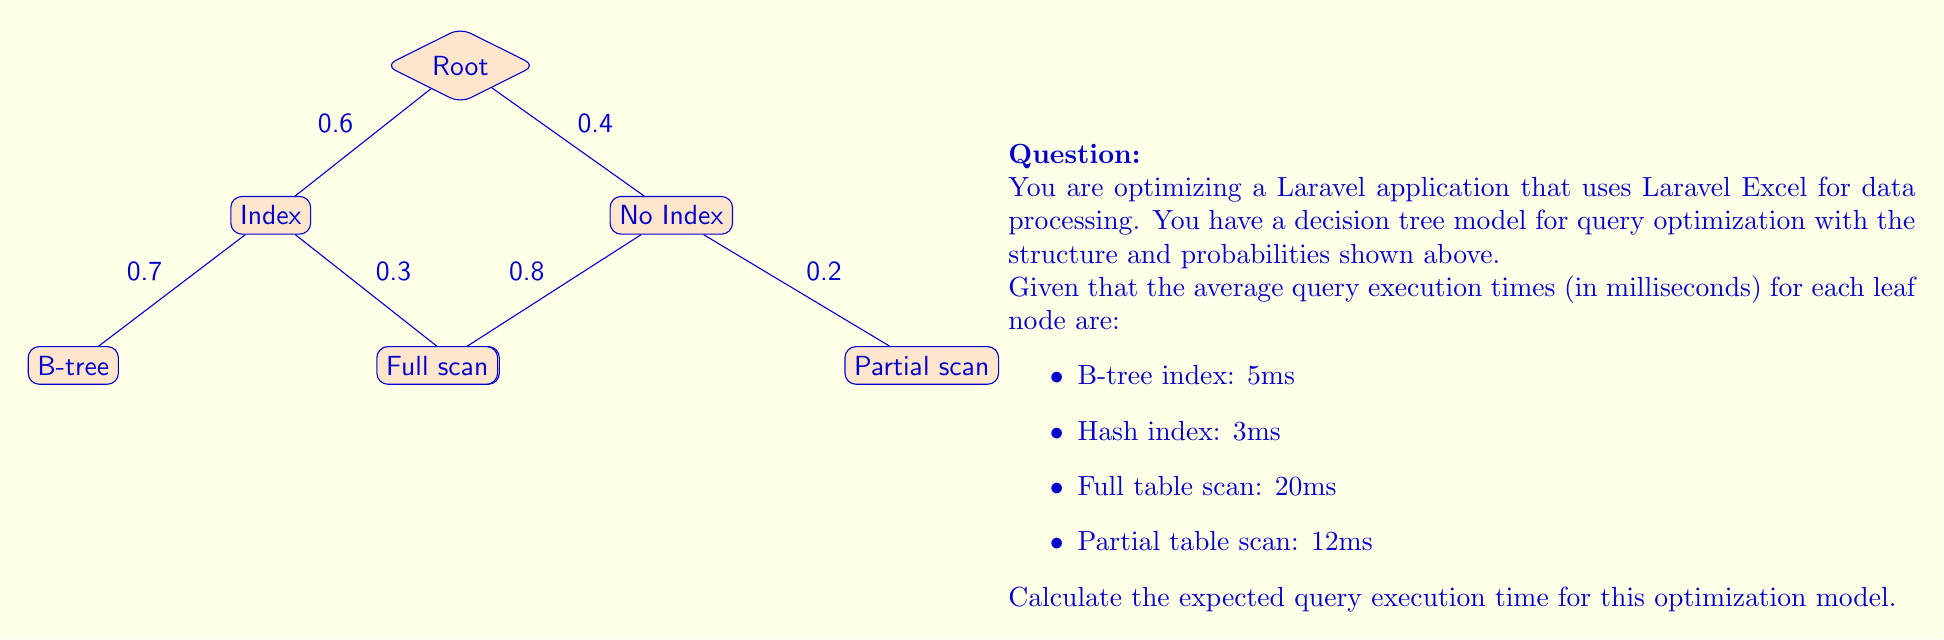Show me your answer to this math problem. To calculate the expected query execution time, we need to follow these steps:

1) First, let's calculate the probability of reaching each leaf node:

   P(B-tree) = 0.6 * 0.7 = 0.42
   P(Hash) = 0.6 * 0.3 = 0.18
   P(Full scan) = 0.4 * 0.8 = 0.32
   P(Partial scan) = 0.4 * 0.2 = 0.08

2) Now, we multiply each probability by its corresponding execution time:

   B-tree: 0.42 * 5ms = 2.1ms
   Hash: 0.18 * 3ms = 0.54ms
   Full scan: 0.32 * 20ms = 6.4ms
   Partial scan: 0.08 * 12ms = 0.96ms

3) The expected execution time is the sum of these values:

   E(execution time) = 2.1 + 0.54 + 6.4 + 0.96 = 10ms

Therefore, the expected query execution time for this optimization model is 10ms.
Answer: 10ms 